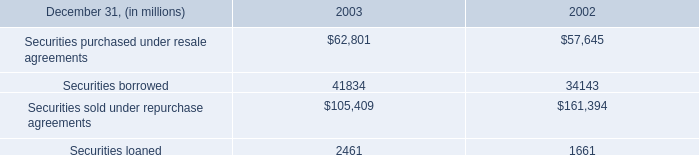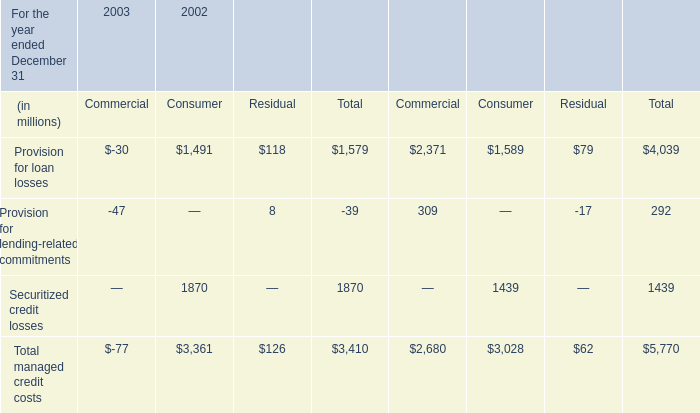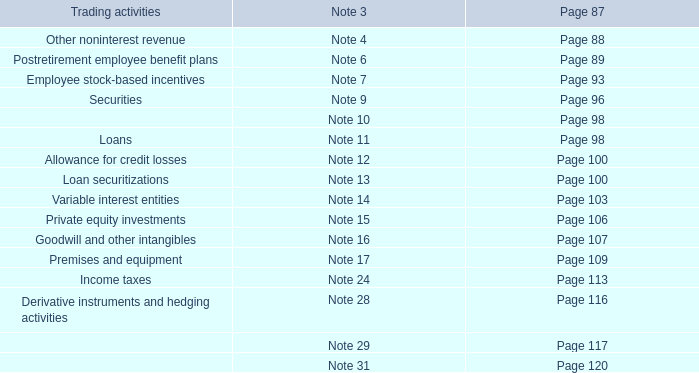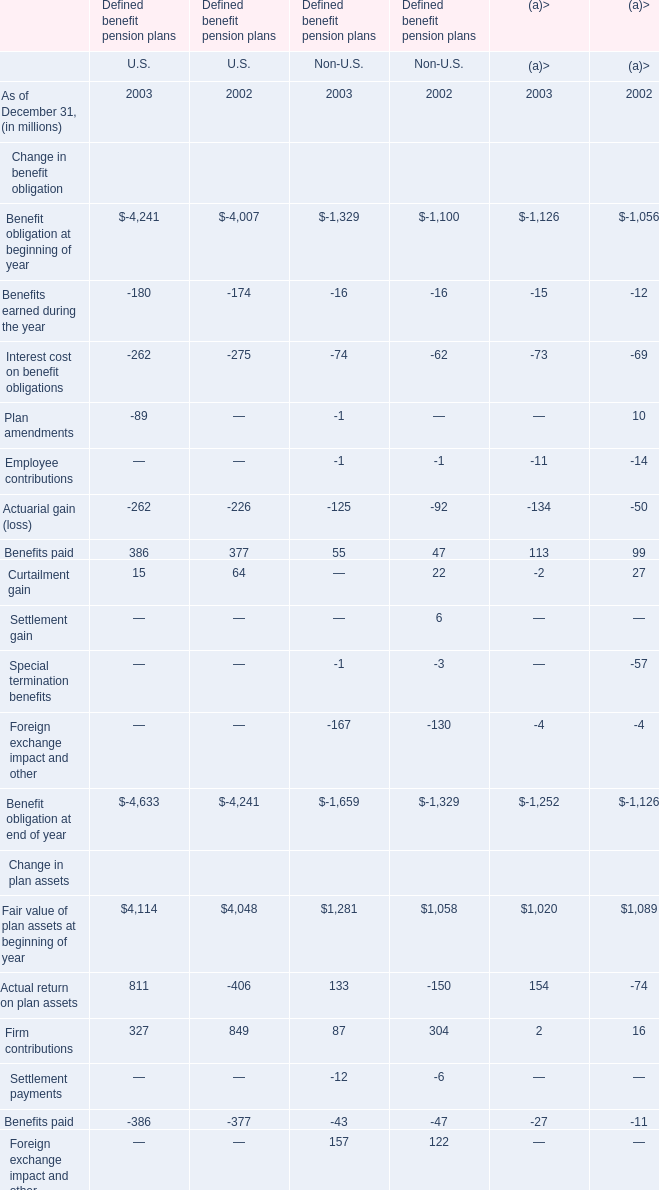What do all Change in benefit obligation of U.S sum up without those Change in benefit obligation of U.S smaller than 0, in 2003? (in millions) 
Computations: (386 + 15)
Answer: 401.0. 